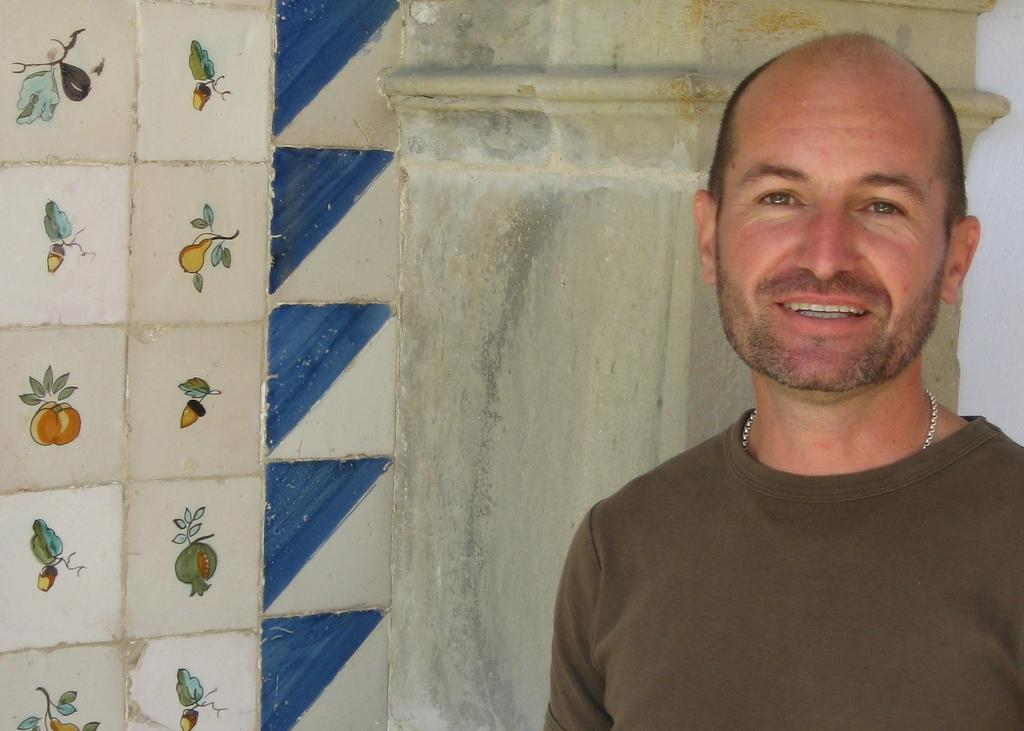What is the main subject of the image? The main subject of the image is a man. Can you describe the man's attire? The man is wearing clothes and a neck chain. What is the man's facial expression? The man is smiling. What type of flooring is visible in the image? There are tiles in the image. Can you identify any architectural features in the image? Yes, there is a pilaster in the image. What type of scissors is the man using to look at the image? There are no scissors present in the image, and the man is not using any to look at the image. 